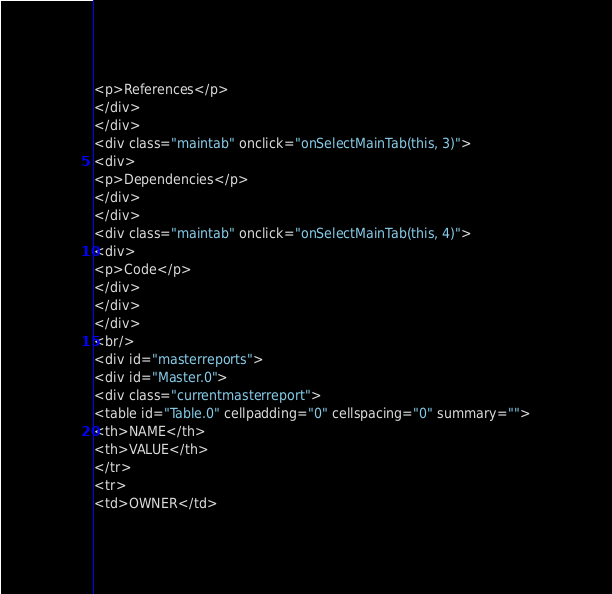Convert code to text. <code><loc_0><loc_0><loc_500><loc_500><_HTML_><p>References</p>
</div>
</div>
<div class="maintab" onclick="onSelectMainTab(this, 3)">
<div>
<p>Dependencies</p>
</div>
</div>
<div class="maintab" onclick="onSelectMainTab(this, 4)">
<div>
<p>Code</p>
</div>
</div>
</div>
<br/>
<div id="masterreports">
<div id="Master.0">
<div class="currentmasterreport">
<table id="Table.0" cellpadding="0" cellspacing="0" summary="">
<th>NAME</th>
<th>VALUE</th>
</tr>
<tr>
<td>OWNER</td></code> 